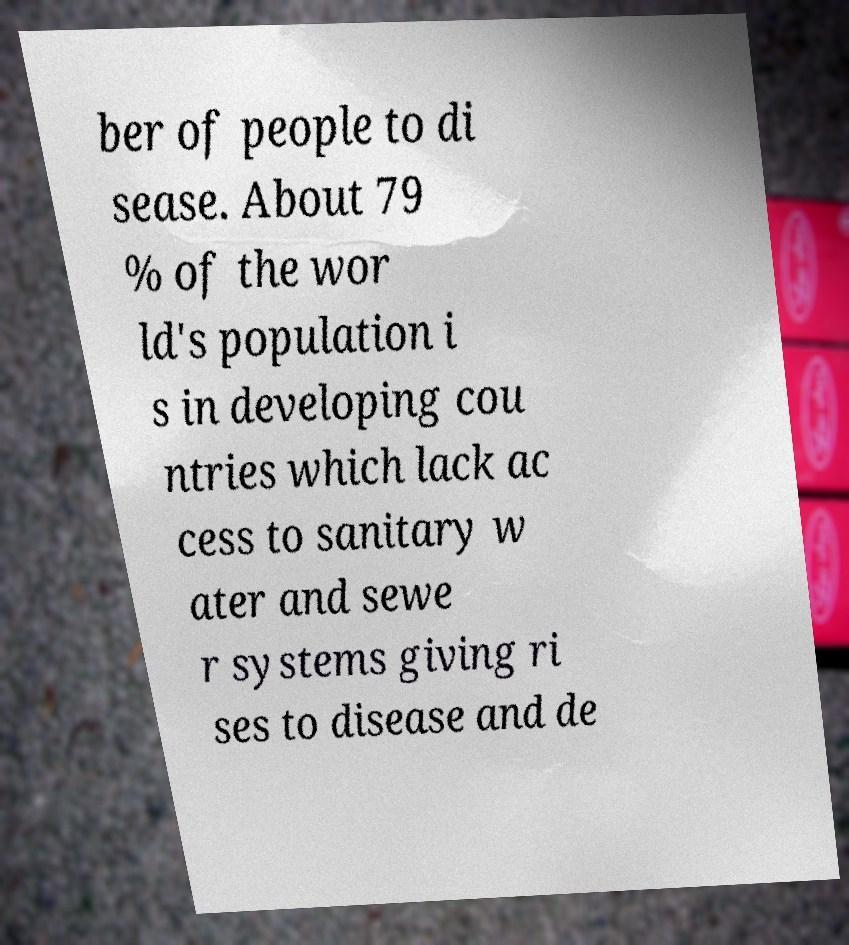Could you extract and type out the text from this image? ber of people to di sease. About 79 % of the wor ld's population i s in developing cou ntries which lack ac cess to sanitary w ater and sewe r systems giving ri ses to disease and de 